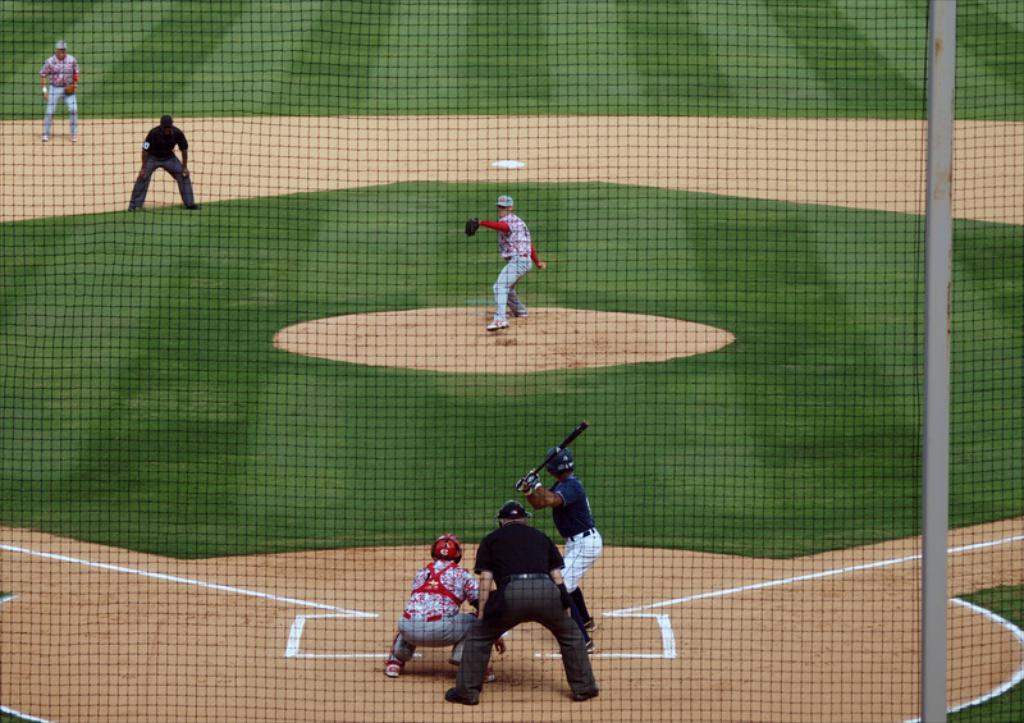What is the main object in the image? There is a net in the image. How is the net positioned or supported? The net is attached to a pole. What activity is taking place near the net? People are playing baseball outside the net. Where is the baseball game being played? The baseball game is taking place on the ground. What type of surface is the ground made of? The ground has grass on it. How many sisters are playing with the tooth in the image? There are no sisters or teeth present in the image. 